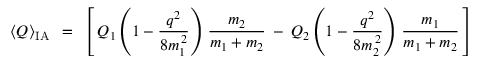<formula> <loc_0><loc_0><loc_500><loc_500>\left < Q \right > _ { I A } \, = \, \left [ \, Q _ { 1 } \left ( 1 - \frac { q ^ { 2 } } { 8 m _ { 1 } ^ { \, 2 } } \right ) \, \frac { m _ { 2 } } { m _ { 1 } + m _ { 2 } } \, - \, Q _ { 2 } \left ( 1 - \frac { q ^ { 2 } } { 8 m _ { 2 } ^ { \, 2 } } \right ) \, \frac { m _ { 1 } } { m _ { 1 } + m _ { 2 } } \, \right ]</formula> 